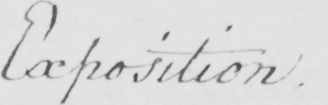What text is written in this handwritten line? Exposition 